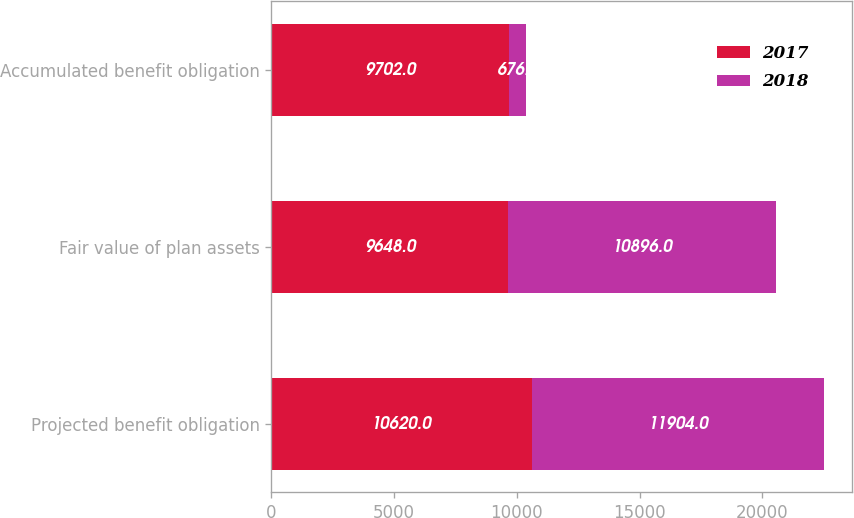Convert chart to OTSL. <chart><loc_0><loc_0><loc_500><loc_500><stacked_bar_chart><ecel><fcel>Projected benefit obligation<fcel>Fair value of plan assets<fcel>Accumulated benefit obligation<nl><fcel>2017<fcel>10620<fcel>9648<fcel>9702<nl><fcel>2018<fcel>11904<fcel>10896<fcel>676<nl></chart> 